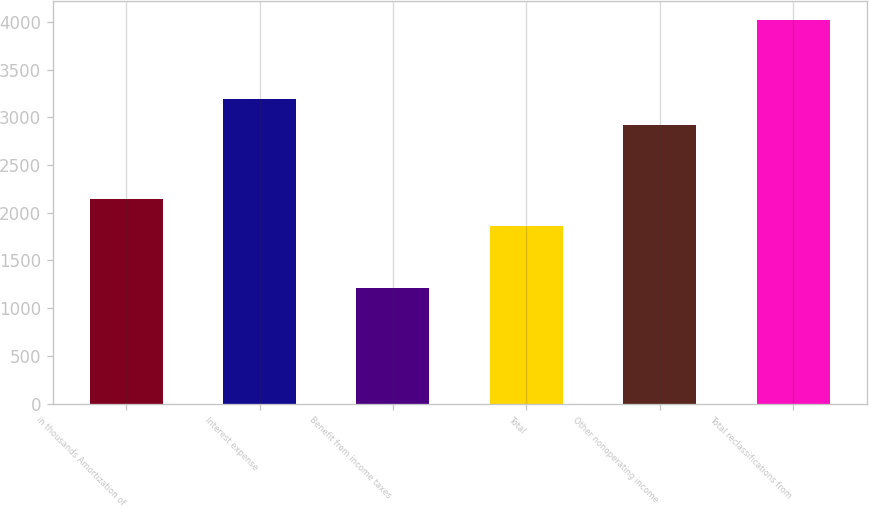Convert chart to OTSL. <chart><loc_0><loc_0><loc_500><loc_500><bar_chart><fcel>in thousands Amortization of<fcel>Interest expense<fcel>Benefit from income taxes<fcel>Total<fcel>Other nonoperating income<fcel>Total reclassifications from<nl><fcel>2142.8<fcel>3195.8<fcel>1208<fcel>1862<fcel>2915<fcel>4016<nl></chart> 